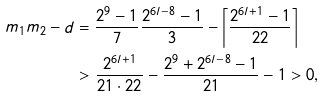<formula> <loc_0><loc_0><loc_500><loc_500>m _ { 1 } m _ { 2 } - d & = \frac { 2 ^ { 9 } - 1 } { 7 } \frac { 2 ^ { 6 l - 8 } - 1 } { 3 } - \left \lceil \frac { 2 ^ { 6 l + 1 } - 1 } { 2 2 } \right \rceil \\ & > \frac { 2 ^ { 6 l + 1 } } { 2 1 \cdot 2 2 } - \frac { 2 ^ { 9 } + 2 ^ { 6 l - 8 } - 1 } { 2 1 } - 1 > 0 ,</formula> 